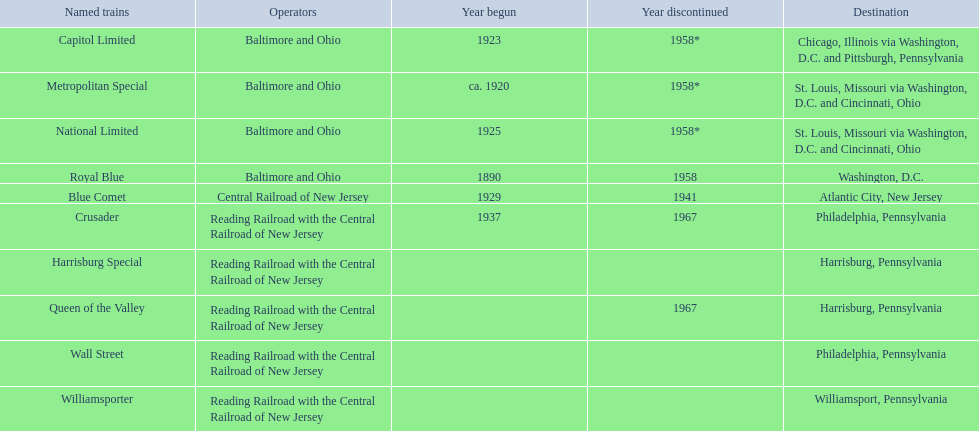What destinations are listed from the central railroad of new jersey terminal? Chicago, Illinois via Washington, D.C. and Pittsburgh, Pennsylvania, St. Louis, Missouri via Washington, D.C. and Cincinnati, Ohio, St. Louis, Missouri via Washington, D.C. and Cincinnati, Ohio, Washington, D.C., Atlantic City, New Jersey, Philadelphia, Pennsylvania, Harrisburg, Pennsylvania, Harrisburg, Pennsylvania, Philadelphia, Pennsylvania, Williamsport, Pennsylvania. Which of these destinations is listed first? Chicago, Illinois via Washington, D.C. and Pittsburgh, Pennsylvania. 